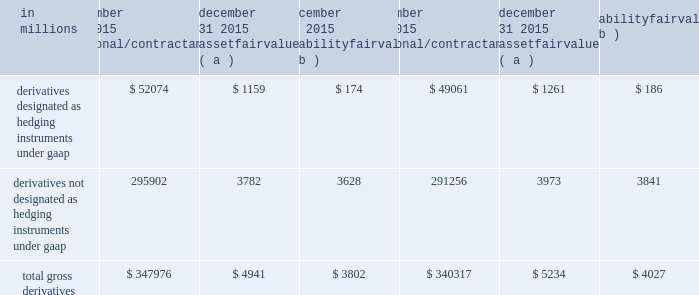In 2011 , we transferred approximately 1.3 million shares of blackrock series c preferred stock to blackrock in connection with our obligation .
In 2013 , we transferred an additional .2 million shares to blackrock .
At december 31 , 2015 , we held approximately 1.3 million shares of blackrock series c preferred stock which were available to fund our obligation in connection with the blackrock ltip programs .
See note 24 subsequent events for information on our february 1 , 2016 transfer of 0.5 million shares of the series c preferred stock to blackrock to satisfy a portion of our ltip obligation .
Pnc accounts for its blackrock series c preferred stock at fair value , which offsets the impact of marking-to-market the obligation to deliver these shares to blackrock .
The fair value of the blackrock series c preferred stock is included on our consolidated balance sheet in the caption other assets .
Additional information regarding the valuation of the blackrock series c preferred stock is included in note 7 fair value .
Note 14 financial derivatives we use derivative financial instruments ( derivatives ) primarily to help manage exposure to interest rate , market and credit risk and reduce the effects that changes in interest rates may have on net income , the fair value of assets and liabilities , and cash flows .
We also enter into derivatives with customers to facilitate their risk management activities .
Derivatives represent contracts between parties that usually require little or no initial net investment and result in one party delivering cash or another type of asset to the other party based on a notional amount and an underlying as specified in the contract .
Derivative transactions are often measured in terms of notional amount , but this amount is generally not exchanged and it is not recorded on the balance sheet .
The notional amount is the basis to which the underlying is applied to determine required payments under the derivative contract .
The underlying is a referenced interest rate ( commonly libor ) , security price , credit spread or other index .
Residential and commercial real estate loan commitments associated with loans to be sold also qualify as derivative instruments .
The table presents the notional amounts and gross fair values of all derivative assets and liabilities held by pnc : table 111 : total gross derivatives .
( a ) included in other assets on our consolidated balance sheet .
( b ) included in other liabilities on our consolidated balance sheet .
All derivatives are carried on our consolidated balance sheet at fair value .
Derivative balances are presented on the consolidated balance sheet on a net basis taking into consideration the effects of legally enforceable master netting agreements and , when appropriate , any related cash collateral exchanged with counterparties .
Further discussion regarding the offsetting rights associated with these legally enforceable master netting agreements is included in the offsetting , counterparty credit risk , and contingent features section below .
Any nonperformance risk , including credit risk , is included in the determination of the estimated net fair value of the derivatives .
Further discussion on how derivatives are accounted for is included in note 1 accounting policies .
Derivatives designated as hedging instruments under gaap certain derivatives used to manage interest rate and foreign exchange risk as part of our asset and liability risk management activities are designated as accounting hedges under gaap .
Derivatives hedging the risks associated with changes in the fair value of assets or liabilities are considered fair value hedges , derivatives hedging the variability of expected future cash flows are considered cash flow hedges , and derivatives hedging a net investment in a foreign subsidiary are considered net investment hedges .
Designating derivatives as accounting hedges allows for gains and losses on those derivatives , to the extent effective , to be recognized in the income statement in the same period the hedged items affect earnings .
180 the pnc financial services group , inc .
2013 form 10-k .
Was the derivatives designated as hedging instruments under gaap greater than the derivatives not designated as hedging instruments under gaap for 2015? 
Computations: (52074 > 295902)
Answer: no. 